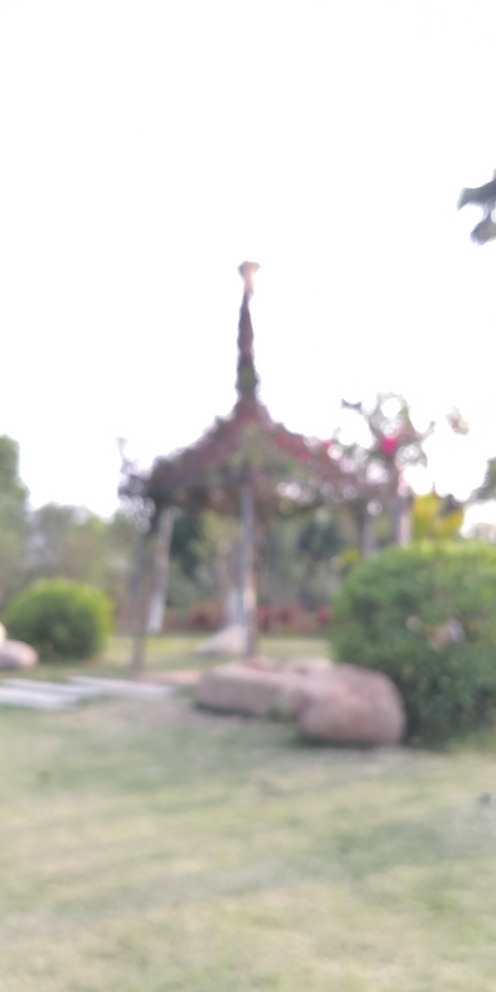Can you describe what this structure might be? Based on the blurred image, it is challenging to provide a detailed description. However, the outline suggests it could be an architectural structure, possibly with a pointed feature at the top that resembles certain styles of roofs or decorations. 